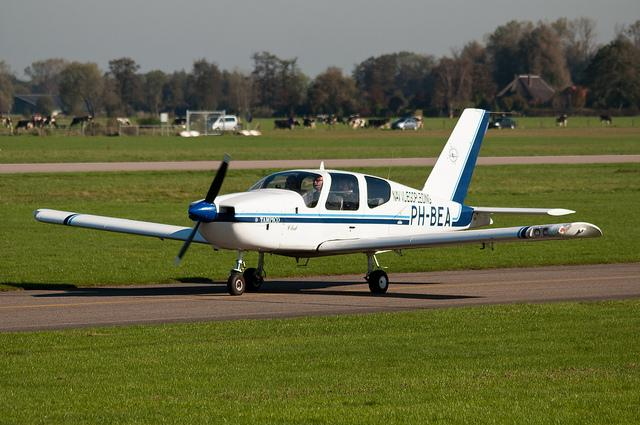What type of settlements are near the airport? farm 